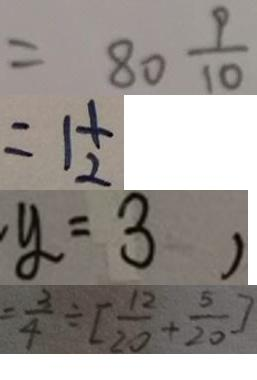Convert formula to latex. <formula><loc_0><loc_0><loc_500><loc_500>= 8 0 \frac { 9 } { 1 0 } 
 = 1 \frac { 1 } { 2 } 
 y = 3 , 
 = \frac { 3 } { 4 } \div [ \frac { 1 2 } { 2 0 } + \frac { 5 } { 2 0 } ]</formula> 